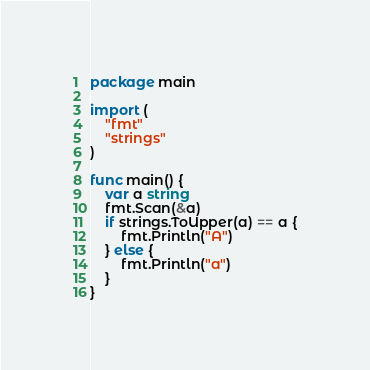Convert code to text. <code><loc_0><loc_0><loc_500><loc_500><_Go_>package main

import (
	"fmt"
	"strings"
)

func main() {
	var a string
	fmt.Scan(&a)
	if strings.ToUpper(a) == a {
		fmt.Println("A")
	} else {
		fmt.Println("a")
	}
}</code> 